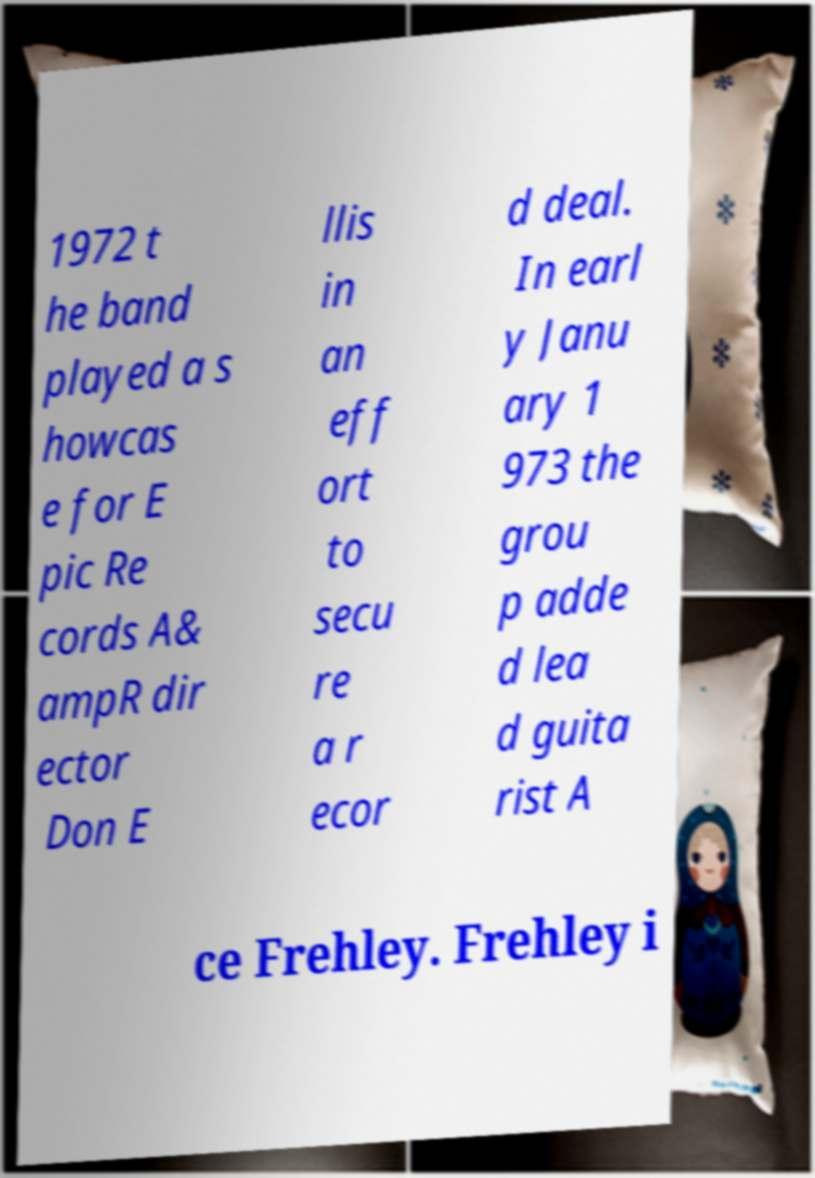For documentation purposes, I need the text within this image transcribed. Could you provide that? 1972 t he band played a s howcas e for E pic Re cords A& ampR dir ector Don E llis in an eff ort to secu re a r ecor d deal. In earl y Janu ary 1 973 the grou p adde d lea d guita rist A ce Frehley. Frehley i 